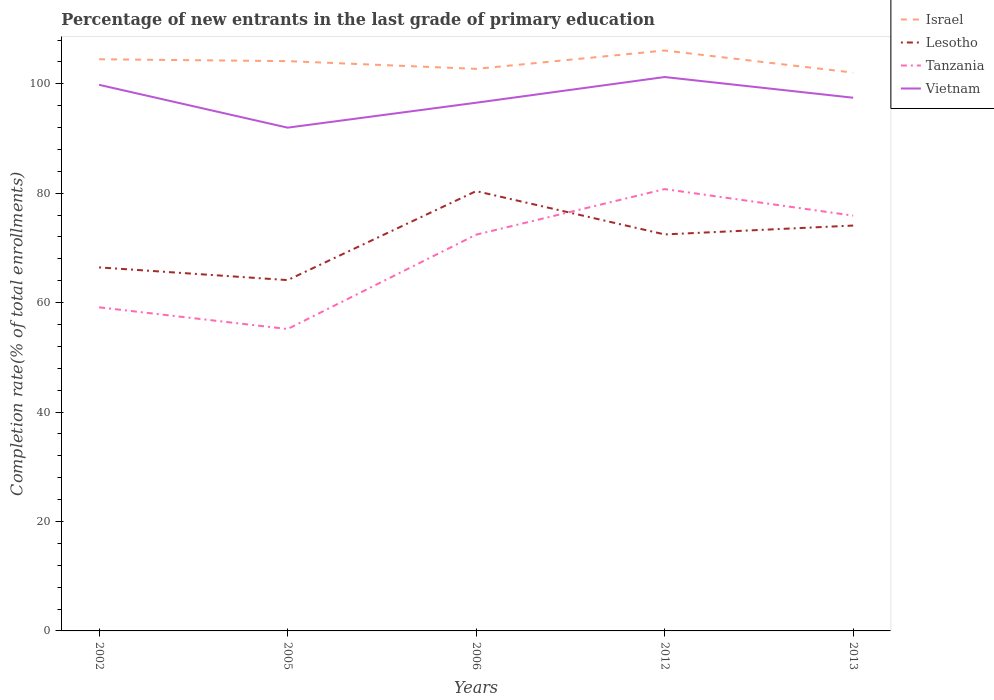Across all years, what is the maximum percentage of new entrants in Lesotho?
Offer a terse response. 64.12. What is the total percentage of new entrants in Vietnam in the graph?
Offer a very short reply. -1.42. What is the difference between the highest and the second highest percentage of new entrants in Israel?
Your response must be concise. 4.04. How many years are there in the graph?
Your response must be concise. 5. What is the difference between two consecutive major ticks on the Y-axis?
Your answer should be compact. 20. Does the graph contain any zero values?
Your answer should be compact. No. Does the graph contain grids?
Offer a very short reply. No. Where does the legend appear in the graph?
Provide a succinct answer. Top right. What is the title of the graph?
Your answer should be compact. Percentage of new entrants in the last grade of primary education. What is the label or title of the X-axis?
Provide a short and direct response. Years. What is the label or title of the Y-axis?
Your response must be concise. Completion rate(% of total enrollments). What is the Completion rate(% of total enrollments) in Israel in 2002?
Ensure brevity in your answer.  104.48. What is the Completion rate(% of total enrollments) of Lesotho in 2002?
Provide a succinct answer. 66.44. What is the Completion rate(% of total enrollments) in Tanzania in 2002?
Your response must be concise. 59.14. What is the Completion rate(% of total enrollments) of Vietnam in 2002?
Give a very brief answer. 99.81. What is the Completion rate(% of total enrollments) of Israel in 2005?
Make the answer very short. 104.14. What is the Completion rate(% of total enrollments) in Lesotho in 2005?
Ensure brevity in your answer.  64.12. What is the Completion rate(% of total enrollments) of Tanzania in 2005?
Keep it short and to the point. 55.18. What is the Completion rate(% of total enrollments) in Vietnam in 2005?
Provide a succinct answer. 91.98. What is the Completion rate(% of total enrollments) in Israel in 2006?
Provide a short and direct response. 102.73. What is the Completion rate(% of total enrollments) in Lesotho in 2006?
Offer a very short reply. 80.39. What is the Completion rate(% of total enrollments) in Tanzania in 2006?
Ensure brevity in your answer.  72.42. What is the Completion rate(% of total enrollments) of Vietnam in 2006?
Give a very brief answer. 96.54. What is the Completion rate(% of total enrollments) in Israel in 2012?
Offer a terse response. 106.08. What is the Completion rate(% of total enrollments) of Lesotho in 2012?
Give a very brief answer. 72.47. What is the Completion rate(% of total enrollments) of Tanzania in 2012?
Provide a short and direct response. 80.75. What is the Completion rate(% of total enrollments) in Vietnam in 2012?
Offer a very short reply. 101.24. What is the Completion rate(% of total enrollments) of Israel in 2013?
Keep it short and to the point. 102.05. What is the Completion rate(% of total enrollments) in Lesotho in 2013?
Provide a succinct answer. 74.09. What is the Completion rate(% of total enrollments) of Tanzania in 2013?
Your answer should be very brief. 75.9. What is the Completion rate(% of total enrollments) of Vietnam in 2013?
Provide a short and direct response. 97.45. Across all years, what is the maximum Completion rate(% of total enrollments) in Israel?
Keep it short and to the point. 106.08. Across all years, what is the maximum Completion rate(% of total enrollments) of Lesotho?
Make the answer very short. 80.39. Across all years, what is the maximum Completion rate(% of total enrollments) in Tanzania?
Provide a short and direct response. 80.75. Across all years, what is the maximum Completion rate(% of total enrollments) in Vietnam?
Give a very brief answer. 101.24. Across all years, what is the minimum Completion rate(% of total enrollments) in Israel?
Keep it short and to the point. 102.05. Across all years, what is the minimum Completion rate(% of total enrollments) in Lesotho?
Offer a terse response. 64.12. Across all years, what is the minimum Completion rate(% of total enrollments) of Tanzania?
Provide a short and direct response. 55.18. Across all years, what is the minimum Completion rate(% of total enrollments) of Vietnam?
Keep it short and to the point. 91.98. What is the total Completion rate(% of total enrollments) of Israel in the graph?
Your response must be concise. 519.48. What is the total Completion rate(% of total enrollments) in Lesotho in the graph?
Offer a terse response. 357.51. What is the total Completion rate(% of total enrollments) in Tanzania in the graph?
Make the answer very short. 343.4. What is the total Completion rate(% of total enrollments) of Vietnam in the graph?
Offer a terse response. 487.02. What is the difference between the Completion rate(% of total enrollments) of Israel in 2002 and that in 2005?
Offer a terse response. 0.34. What is the difference between the Completion rate(% of total enrollments) in Lesotho in 2002 and that in 2005?
Ensure brevity in your answer.  2.32. What is the difference between the Completion rate(% of total enrollments) of Tanzania in 2002 and that in 2005?
Keep it short and to the point. 3.97. What is the difference between the Completion rate(% of total enrollments) in Vietnam in 2002 and that in 2005?
Make the answer very short. 7.83. What is the difference between the Completion rate(% of total enrollments) of Israel in 2002 and that in 2006?
Keep it short and to the point. 1.76. What is the difference between the Completion rate(% of total enrollments) of Lesotho in 2002 and that in 2006?
Your answer should be compact. -13.94. What is the difference between the Completion rate(% of total enrollments) in Tanzania in 2002 and that in 2006?
Give a very brief answer. -13.28. What is the difference between the Completion rate(% of total enrollments) of Vietnam in 2002 and that in 2006?
Make the answer very short. 3.27. What is the difference between the Completion rate(% of total enrollments) of Israel in 2002 and that in 2012?
Provide a succinct answer. -1.6. What is the difference between the Completion rate(% of total enrollments) of Lesotho in 2002 and that in 2012?
Give a very brief answer. -6.03. What is the difference between the Completion rate(% of total enrollments) of Tanzania in 2002 and that in 2012?
Provide a succinct answer. -21.61. What is the difference between the Completion rate(% of total enrollments) of Vietnam in 2002 and that in 2012?
Your answer should be very brief. -1.42. What is the difference between the Completion rate(% of total enrollments) in Israel in 2002 and that in 2013?
Offer a terse response. 2.44. What is the difference between the Completion rate(% of total enrollments) in Lesotho in 2002 and that in 2013?
Give a very brief answer. -7.65. What is the difference between the Completion rate(% of total enrollments) in Tanzania in 2002 and that in 2013?
Your answer should be very brief. -16.76. What is the difference between the Completion rate(% of total enrollments) of Vietnam in 2002 and that in 2013?
Your response must be concise. 2.36. What is the difference between the Completion rate(% of total enrollments) of Israel in 2005 and that in 2006?
Your answer should be very brief. 1.42. What is the difference between the Completion rate(% of total enrollments) in Lesotho in 2005 and that in 2006?
Offer a very short reply. -16.27. What is the difference between the Completion rate(% of total enrollments) in Tanzania in 2005 and that in 2006?
Offer a very short reply. -17.24. What is the difference between the Completion rate(% of total enrollments) in Vietnam in 2005 and that in 2006?
Make the answer very short. -4.56. What is the difference between the Completion rate(% of total enrollments) in Israel in 2005 and that in 2012?
Your answer should be very brief. -1.94. What is the difference between the Completion rate(% of total enrollments) in Lesotho in 2005 and that in 2012?
Provide a succinct answer. -8.35. What is the difference between the Completion rate(% of total enrollments) in Tanzania in 2005 and that in 2012?
Your answer should be compact. -25.57. What is the difference between the Completion rate(% of total enrollments) in Vietnam in 2005 and that in 2012?
Offer a terse response. -9.25. What is the difference between the Completion rate(% of total enrollments) of Israel in 2005 and that in 2013?
Ensure brevity in your answer.  2.1. What is the difference between the Completion rate(% of total enrollments) in Lesotho in 2005 and that in 2013?
Make the answer very short. -9.97. What is the difference between the Completion rate(% of total enrollments) of Tanzania in 2005 and that in 2013?
Make the answer very short. -20.73. What is the difference between the Completion rate(% of total enrollments) of Vietnam in 2005 and that in 2013?
Offer a very short reply. -5.47. What is the difference between the Completion rate(% of total enrollments) in Israel in 2006 and that in 2012?
Provide a succinct answer. -3.36. What is the difference between the Completion rate(% of total enrollments) of Lesotho in 2006 and that in 2012?
Your answer should be compact. 7.92. What is the difference between the Completion rate(% of total enrollments) of Tanzania in 2006 and that in 2012?
Keep it short and to the point. -8.33. What is the difference between the Completion rate(% of total enrollments) in Vietnam in 2006 and that in 2012?
Give a very brief answer. -4.7. What is the difference between the Completion rate(% of total enrollments) in Israel in 2006 and that in 2013?
Provide a succinct answer. 0.68. What is the difference between the Completion rate(% of total enrollments) in Lesotho in 2006 and that in 2013?
Provide a short and direct response. 6.3. What is the difference between the Completion rate(% of total enrollments) of Tanzania in 2006 and that in 2013?
Provide a succinct answer. -3.48. What is the difference between the Completion rate(% of total enrollments) of Vietnam in 2006 and that in 2013?
Give a very brief answer. -0.91. What is the difference between the Completion rate(% of total enrollments) in Israel in 2012 and that in 2013?
Offer a very short reply. 4.04. What is the difference between the Completion rate(% of total enrollments) of Lesotho in 2012 and that in 2013?
Offer a terse response. -1.62. What is the difference between the Completion rate(% of total enrollments) in Tanzania in 2012 and that in 2013?
Your answer should be compact. 4.85. What is the difference between the Completion rate(% of total enrollments) of Vietnam in 2012 and that in 2013?
Your response must be concise. 3.78. What is the difference between the Completion rate(% of total enrollments) of Israel in 2002 and the Completion rate(% of total enrollments) of Lesotho in 2005?
Provide a succinct answer. 40.36. What is the difference between the Completion rate(% of total enrollments) of Israel in 2002 and the Completion rate(% of total enrollments) of Tanzania in 2005?
Give a very brief answer. 49.31. What is the difference between the Completion rate(% of total enrollments) in Israel in 2002 and the Completion rate(% of total enrollments) in Vietnam in 2005?
Keep it short and to the point. 12.5. What is the difference between the Completion rate(% of total enrollments) in Lesotho in 2002 and the Completion rate(% of total enrollments) in Tanzania in 2005?
Your answer should be compact. 11.26. What is the difference between the Completion rate(% of total enrollments) in Lesotho in 2002 and the Completion rate(% of total enrollments) in Vietnam in 2005?
Ensure brevity in your answer.  -25.54. What is the difference between the Completion rate(% of total enrollments) in Tanzania in 2002 and the Completion rate(% of total enrollments) in Vietnam in 2005?
Give a very brief answer. -32.84. What is the difference between the Completion rate(% of total enrollments) of Israel in 2002 and the Completion rate(% of total enrollments) of Lesotho in 2006?
Offer a terse response. 24.1. What is the difference between the Completion rate(% of total enrollments) of Israel in 2002 and the Completion rate(% of total enrollments) of Tanzania in 2006?
Provide a succinct answer. 32.06. What is the difference between the Completion rate(% of total enrollments) in Israel in 2002 and the Completion rate(% of total enrollments) in Vietnam in 2006?
Make the answer very short. 7.95. What is the difference between the Completion rate(% of total enrollments) of Lesotho in 2002 and the Completion rate(% of total enrollments) of Tanzania in 2006?
Your answer should be compact. -5.98. What is the difference between the Completion rate(% of total enrollments) in Lesotho in 2002 and the Completion rate(% of total enrollments) in Vietnam in 2006?
Offer a very short reply. -30.1. What is the difference between the Completion rate(% of total enrollments) in Tanzania in 2002 and the Completion rate(% of total enrollments) in Vietnam in 2006?
Ensure brevity in your answer.  -37.39. What is the difference between the Completion rate(% of total enrollments) in Israel in 2002 and the Completion rate(% of total enrollments) in Lesotho in 2012?
Keep it short and to the point. 32.02. What is the difference between the Completion rate(% of total enrollments) of Israel in 2002 and the Completion rate(% of total enrollments) of Tanzania in 2012?
Make the answer very short. 23.73. What is the difference between the Completion rate(% of total enrollments) of Israel in 2002 and the Completion rate(% of total enrollments) of Vietnam in 2012?
Your response must be concise. 3.25. What is the difference between the Completion rate(% of total enrollments) of Lesotho in 2002 and the Completion rate(% of total enrollments) of Tanzania in 2012?
Offer a terse response. -14.31. What is the difference between the Completion rate(% of total enrollments) of Lesotho in 2002 and the Completion rate(% of total enrollments) of Vietnam in 2012?
Offer a terse response. -34.79. What is the difference between the Completion rate(% of total enrollments) in Tanzania in 2002 and the Completion rate(% of total enrollments) in Vietnam in 2012?
Provide a succinct answer. -42.09. What is the difference between the Completion rate(% of total enrollments) in Israel in 2002 and the Completion rate(% of total enrollments) in Lesotho in 2013?
Provide a succinct answer. 30.39. What is the difference between the Completion rate(% of total enrollments) in Israel in 2002 and the Completion rate(% of total enrollments) in Tanzania in 2013?
Your response must be concise. 28.58. What is the difference between the Completion rate(% of total enrollments) of Israel in 2002 and the Completion rate(% of total enrollments) of Vietnam in 2013?
Your response must be concise. 7.03. What is the difference between the Completion rate(% of total enrollments) of Lesotho in 2002 and the Completion rate(% of total enrollments) of Tanzania in 2013?
Provide a succinct answer. -9.46. What is the difference between the Completion rate(% of total enrollments) of Lesotho in 2002 and the Completion rate(% of total enrollments) of Vietnam in 2013?
Provide a succinct answer. -31.01. What is the difference between the Completion rate(% of total enrollments) of Tanzania in 2002 and the Completion rate(% of total enrollments) of Vietnam in 2013?
Offer a very short reply. -38.31. What is the difference between the Completion rate(% of total enrollments) in Israel in 2005 and the Completion rate(% of total enrollments) in Lesotho in 2006?
Ensure brevity in your answer.  23.76. What is the difference between the Completion rate(% of total enrollments) of Israel in 2005 and the Completion rate(% of total enrollments) of Tanzania in 2006?
Offer a terse response. 31.72. What is the difference between the Completion rate(% of total enrollments) in Israel in 2005 and the Completion rate(% of total enrollments) in Vietnam in 2006?
Offer a terse response. 7.6. What is the difference between the Completion rate(% of total enrollments) of Lesotho in 2005 and the Completion rate(% of total enrollments) of Tanzania in 2006?
Offer a terse response. -8.3. What is the difference between the Completion rate(% of total enrollments) in Lesotho in 2005 and the Completion rate(% of total enrollments) in Vietnam in 2006?
Ensure brevity in your answer.  -32.42. What is the difference between the Completion rate(% of total enrollments) in Tanzania in 2005 and the Completion rate(% of total enrollments) in Vietnam in 2006?
Offer a terse response. -41.36. What is the difference between the Completion rate(% of total enrollments) of Israel in 2005 and the Completion rate(% of total enrollments) of Lesotho in 2012?
Make the answer very short. 31.67. What is the difference between the Completion rate(% of total enrollments) in Israel in 2005 and the Completion rate(% of total enrollments) in Tanzania in 2012?
Your response must be concise. 23.39. What is the difference between the Completion rate(% of total enrollments) of Israel in 2005 and the Completion rate(% of total enrollments) of Vietnam in 2012?
Provide a short and direct response. 2.91. What is the difference between the Completion rate(% of total enrollments) in Lesotho in 2005 and the Completion rate(% of total enrollments) in Tanzania in 2012?
Give a very brief answer. -16.63. What is the difference between the Completion rate(% of total enrollments) in Lesotho in 2005 and the Completion rate(% of total enrollments) in Vietnam in 2012?
Keep it short and to the point. -37.12. What is the difference between the Completion rate(% of total enrollments) in Tanzania in 2005 and the Completion rate(% of total enrollments) in Vietnam in 2012?
Keep it short and to the point. -46.06. What is the difference between the Completion rate(% of total enrollments) in Israel in 2005 and the Completion rate(% of total enrollments) in Lesotho in 2013?
Your response must be concise. 30.05. What is the difference between the Completion rate(% of total enrollments) in Israel in 2005 and the Completion rate(% of total enrollments) in Tanzania in 2013?
Give a very brief answer. 28.24. What is the difference between the Completion rate(% of total enrollments) of Israel in 2005 and the Completion rate(% of total enrollments) of Vietnam in 2013?
Keep it short and to the point. 6.69. What is the difference between the Completion rate(% of total enrollments) of Lesotho in 2005 and the Completion rate(% of total enrollments) of Tanzania in 2013?
Give a very brief answer. -11.78. What is the difference between the Completion rate(% of total enrollments) in Lesotho in 2005 and the Completion rate(% of total enrollments) in Vietnam in 2013?
Offer a very short reply. -33.33. What is the difference between the Completion rate(% of total enrollments) in Tanzania in 2005 and the Completion rate(% of total enrollments) in Vietnam in 2013?
Provide a succinct answer. -42.27. What is the difference between the Completion rate(% of total enrollments) in Israel in 2006 and the Completion rate(% of total enrollments) in Lesotho in 2012?
Offer a very short reply. 30.26. What is the difference between the Completion rate(% of total enrollments) in Israel in 2006 and the Completion rate(% of total enrollments) in Tanzania in 2012?
Your response must be concise. 21.97. What is the difference between the Completion rate(% of total enrollments) in Israel in 2006 and the Completion rate(% of total enrollments) in Vietnam in 2012?
Offer a terse response. 1.49. What is the difference between the Completion rate(% of total enrollments) in Lesotho in 2006 and the Completion rate(% of total enrollments) in Tanzania in 2012?
Your answer should be very brief. -0.37. What is the difference between the Completion rate(% of total enrollments) in Lesotho in 2006 and the Completion rate(% of total enrollments) in Vietnam in 2012?
Provide a short and direct response. -20.85. What is the difference between the Completion rate(% of total enrollments) in Tanzania in 2006 and the Completion rate(% of total enrollments) in Vietnam in 2012?
Offer a terse response. -28.81. What is the difference between the Completion rate(% of total enrollments) in Israel in 2006 and the Completion rate(% of total enrollments) in Lesotho in 2013?
Provide a short and direct response. 28.64. What is the difference between the Completion rate(% of total enrollments) in Israel in 2006 and the Completion rate(% of total enrollments) in Tanzania in 2013?
Provide a short and direct response. 26.82. What is the difference between the Completion rate(% of total enrollments) in Israel in 2006 and the Completion rate(% of total enrollments) in Vietnam in 2013?
Keep it short and to the point. 5.27. What is the difference between the Completion rate(% of total enrollments) in Lesotho in 2006 and the Completion rate(% of total enrollments) in Tanzania in 2013?
Keep it short and to the point. 4.48. What is the difference between the Completion rate(% of total enrollments) of Lesotho in 2006 and the Completion rate(% of total enrollments) of Vietnam in 2013?
Make the answer very short. -17.07. What is the difference between the Completion rate(% of total enrollments) in Tanzania in 2006 and the Completion rate(% of total enrollments) in Vietnam in 2013?
Offer a very short reply. -25.03. What is the difference between the Completion rate(% of total enrollments) of Israel in 2012 and the Completion rate(% of total enrollments) of Lesotho in 2013?
Your answer should be compact. 31.99. What is the difference between the Completion rate(% of total enrollments) of Israel in 2012 and the Completion rate(% of total enrollments) of Tanzania in 2013?
Provide a succinct answer. 30.18. What is the difference between the Completion rate(% of total enrollments) in Israel in 2012 and the Completion rate(% of total enrollments) in Vietnam in 2013?
Your answer should be very brief. 8.63. What is the difference between the Completion rate(% of total enrollments) in Lesotho in 2012 and the Completion rate(% of total enrollments) in Tanzania in 2013?
Provide a short and direct response. -3.44. What is the difference between the Completion rate(% of total enrollments) in Lesotho in 2012 and the Completion rate(% of total enrollments) in Vietnam in 2013?
Make the answer very short. -24.98. What is the difference between the Completion rate(% of total enrollments) of Tanzania in 2012 and the Completion rate(% of total enrollments) of Vietnam in 2013?
Keep it short and to the point. -16.7. What is the average Completion rate(% of total enrollments) of Israel per year?
Offer a very short reply. 103.9. What is the average Completion rate(% of total enrollments) of Lesotho per year?
Ensure brevity in your answer.  71.5. What is the average Completion rate(% of total enrollments) of Tanzania per year?
Make the answer very short. 68.68. What is the average Completion rate(% of total enrollments) in Vietnam per year?
Your response must be concise. 97.4. In the year 2002, what is the difference between the Completion rate(% of total enrollments) in Israel and Completion rate(% of total enrollments) in Lesotho?
Give a very brief answer. 38.04. In the year 2002, what is the difference between the Completion rate(% of total enrollments) in Israel and Completion rate(% of total enrollments) in Tanzania?
Your answer should be compact. 45.34. In the year 2002, what is the difference between the Completion rate(% of total enrollments) of Israel and Completion rate(% of total enrollments) of Vietnam?
Your answer should be very brief. 4.67. In the year 2002, what is the difference between the Completion rate(% of total enrollments) in Lesotho and Completion rate(% of total enrollments) in Tanzania?
Keep it short and to the point. 7.3. In the year 2002, what is the difference between the Completion rate(% of total enrollments) of Lesotho and Completion rate(% of total enrollments) of Vietnam?
Offer a very short reply. -33.37. In the year 2002, what is the difference between the Completion rate(% of total enrollments) of Tanzania and Completion rate(% of total enrollments) of Vietnam?
Keep it short and to the point. -40.67. In the year 2005, what is the difference between the Completion rate(% of total enrollments) of Israel and Completion rate(% of total enrollments) of Lesotho?
Your answer should be very brief. 40.02. In the year 2005, what is the difference between the Completion rate(% of total enrollments) in Israel and Completion rate(% of total enrollments) in Tanzania?
Offer a terse response. 48.96. In the year 2005, what is the difference between the Completion rate(% of total enrollments) of Israel and Completion rate(% of total enrollments) of Vietnam?
Your answer should be very brief. 12.16. In the year 2005, what is the difference between the Completion rate(% of total enrollments) in Lesotho and Completion rate(% of total enrollments) in Tanzania?
Provide a succinct answer. 8.94. In the year 2005, what is the difference between the Completion rate(% of total enrollments) of Lesotho and Completion rate(% of total enrollments) of Vietnam?
Make the answer very short. -27.86. In the year 2005, what is the difference between the Completion rate(% of total enrollments) of Tanzania and Completion rate(% of total enrollments) of Vietnam?
Offer a terse response. -36.8. In the year 2006, what is the difference between the Completion rate(% of total enrollments) of Israel and Completion rate(% of total enrollments) of Lesotho?
Provide a short and direct response. 22.34. In the year 2006, what is the difference between the Completion rate(% of total enrollments) in Israel and Completion rate(% of total enrollments) in Tanzania?
Provide a short and direct response. 30.3. In the year 2006, what is the difference between the Completion rate(% of total enrollments) of Israel and Completion rate(% of total enrollments) of Vietnam?
Your answer should be very brief. 6.19. In the year 2006, what is the difference between the Completion rate(% of total enrollments) of Lesotho and Completion rate(% of total enrollments) of Tanzania?
Provide a short and direct response. 7.96. In the year 2006, what is the difference between the Completion rate(% of total enrollments) of Lesotho and Completion rate(% of total enrollments) of Vietnam?
Make the answer very short. -16.15. In the year 2006, what is the difference between the Completion rate(% of total enrollments) in Tanzania and Completion rate(% of total enrollments) in Vietnam?
Provide a short and direct response. -24.12. In the year 2012, what is the difference between the Completion rate(% of total enrollments) in Israel and Completion rate(% of total enrollments) in Lesotho?
Ensure brevity in your answer.  33.62. In the year 2012, what is the difference between the Completion rate(% of total enrollments) of Israel and Completion rate(% of total enrollments) of Tanzania?
Offer a terse response. 25.33. In the year 2012, what is the difference between the Completion rate(% of total enrollments) of Israel and Completion rate(% of total enrollments) of Vietnam?
Your answer should be compact. 4.85. In the year 2012, what is the difference between the Completion rate(% of total enrollments) in Lesotho and Completion rate(% of total enrollments) in Tanzania?
Make the answer very short. -8.28. In the year 2012, what is the difference between the Completion rate(% of total enrollments) of Lesotho and Completion rate(% of total enrollments) of Vietnam?
Keep it short and to the point. -28.77. In the year 2012, what is the difference between the Completion rate(% of total enrollments) in Tanzania and Completion rate(% of total enrollments) in Vietnam?
Offer a terse response. -20.48. In the year 2013, what is the difference between the Completion rate(% of total enrollments) in Israel and Completion rate(% of total enrollments) in Lesotho?
Offer a terse response. 27.96. In the year 2013, what is the difference between the Completion rate(% of total enrollments) in Israel and Completion rate(% of total enrollments) in Tanzania?
Your answer should be compact. 26.14. In the year 2013, what is the difference between the Completion rate(% of total enrollments) of Israel and Completion rate(% of total enrollments) of Vietnam?
Give a very brief answer. 4.59. In the year 2013, what is the difference between the Completion rate(% of total enrollments) of Lesotho and Completion rate(% of total enrollments) of Tanzania?
Provide a succinct answer. -1.81. In the year 2013, what is the difference between the Completion rate(% of total enrollments) of Lesotho and Completion rate(% of total enrollments) of Vietnam?
Your answer should be very brief. -23.36. In the year 2013, what is the difference between the Completion rate(% of total enrollments) of Tanzania and Completion rate(% of total enrollments) of Vietnam?
Your answer should be compact. -21.55. What is the ratio of the Completion rate(% of total enrollments) of Lesotho in 2002 to that in 2005?
Give a very brief answer. 1.04. What is the ratio of the Completion rate(% of total enrollments) of Tanzania in 2002 to that in 2005?
Provide a succinct answer. 1.07. What is the ratio of the Completion rate(% of total enrollments) in Vietnam in 2002 to that in 2005?
Your answer should be very brief. 1.09. What is the ratio of the Completion rate(% of total enrollments) of Israel in 2002 to that in 2006?
Offer a terse response. 1.02. What is the ratio of the Completion rate(% of total enrollments) of Lesotho in 2002 to that in 2006?
Keep it short and to the point. 0.83. What is the ratio of the Completion rate(% of total enrollments) in Tanzania in 2002 to that in 2006?
Ensure brevity in your answer.  0.82. What is the ratio of the Completion rate(% of total enrollments) of Vietnam in 2002 to that in 2006?
Provide a short and direct response. 1.03. What is the ratio of the Completion rate(% of total enrollments) of Israel in 2002 to that in 2012?
Your response must be concise. 0.98. What is the ratio of the Completion rate(% of total enrollments) in Lesotho in 2002 to that in 2012?
Offer a very short reply. 0.92. What is the ratio of the Completion rate(% of total enrollments) in Tanzania in 2002 to that in 2012?
Offer a terse response. 0.73. What is the ratio of the Completion rate(% of total enrollments) in Vietnam in 2002 to that in 2012?
Give a very brief answer. 0.99. What is the ratio of the Completion rate(% of total enrollments) of Israel in 2002 to that in 2013?
Provide a succinct answer. 1.02. What is the ratio of the Completion rate(% of total enrollments) in Lesotho in 2002 to that in 2013?
Provide a short and direct response. 0.9. What is the ratio of the Completion rate(% of total enrollments) in Tanzania in 2002 to that in 2013?
Give a very brief answer. 0.78. What is the ratio of the Completion rate(% of total enrollments) in Vietnam in 2002 to that in 2013?
Your response must be concise. 1.02. What is the ratio of the Completion rate(% of total enrollments) in Israel in 2005 to that in 2006?
Offer a terse response. 1.01. What is the ratio of the Completion rate(% of total enrollments) of Lesotho in 2005 to that in 2006?
Provide a short and direct response. 0.8. What is the ratio of the Completion rate(% of total enrollments) of Tanzania in 2005 to that in 2006?
Your answer should be compact. 0.76. What is the ratio of the Completion rate(% of total enrollments) of Vietnam in 2005 to that in 2006?
Your answer should be compact. 0.95. What is the ratio of the Completion rate(% of total enrollments) in Israel in 2005 to that in 2012?
Your answer should be very brief. 0.98. What is the ratio of the Completion rate(% of total enrollments) in Lesotho in 2005 to that in 2012?
Your answer should be compact. 0.88. What is the ratio of the Completion rate(% of total enrollments) in Tanzania in 2005 to that in 2012?
Your answer should be very brief. 0.68. What is the ratio of the Completion rate(% of total enrollments) of Vietnam in 2005 to that in 2012?
Offer a terse response. 0.91. What is the ratio of the Completion rate(% of total enrollments) of Israel in 2005 to that in 2013?
Your answer should be compact. 1.02. What is the ratio of the Completion rate(% of total enrollments) of Lesotho in 2005 to that in 2013?
Keep it short and to the point. 0.87. What is the ratio of the Completion rate(% of total enrollments) of Tanzania in 2005 to that in 2013?
Provide a succinct answer. 0.73. What is the ratio of the Completion rate(% of total enrollments) in Vietnam in 2005 to that in 2013?
Offer a very short reply. 0.94. What is the ratio of the Completion rate(% of total enrollments) of Israel in 2006 to that in 2012?
Offer a terse response. 0.97. What is the ratio of the Completion rate(% of total enrollments) in Lesotho in 2006 to that in 2012?
Your response must be concise. 1.11. What is the ratio of the Completion rate(% of total enrollments) in Tanzania in 2006 to that in 2012?
Keep it short and to the point. 0.9. What is the ratio of the Completion rate(% of total enrollments) of Vietnam in 2006 to that in 2012?
Make the answer very short. 0.95. What is the ratio of the Completion rate(% of total enrollments) in Israel in 2006 to that in 2013?
Offer a terse response. 1.01. What is the ratio of the Completion rate(% of total enrollments) in Lesotho in 2006 to that in 2013?
Your answer should be compact. 1.08. What is the ratio of the Completion rate(% of total enrollments) of Tanzania in 2006 to that in 2013?
Your answer should be very brief. 0.95. What is the ratio of the Completion rate(% of total enrollments) in Vietnam in 2006 to that in 2013?
Ensure brevity in your answer.  0.99. What is the ratio of the Completion rate(% of total enrollments) of Israel in 2012 to that in 2013?
Give a very brief answer. 1.04. What is the ratio of the Completion rate(% of total enrollments) in Lesotho in 2012 to that in 2013?
Provide a succinct answer. 0.98. What is the ratio of the Completion rate(% of total enrollments) in Tanzania in 2012 to that in 2013?
Provide a short and direct response. 1.06. What is the ratio of the Completion rate(% of total enrollments) in Vietnam in 2012 to that in 2013?
Your answer should be compact. 1.04. What is the difference between the highest and the second highest Completion rate(% of total enrollments) of Israel?
Your answer should be very brief. 1.6. What is the difference between the highest and the second highest Completion rate(% of total enrollments) in Lesotho?
Your response must be concise. 6.3. What is the difference between the highest and the second highest Completion rate(% of total enrollments) in Tanzania?
Give a very brief answer. 4.85. What is the difference between the highest and the second highest Completion rate(% of total enrollments) in Vietnam?
Your answer should be compact. 1.42. What is the difference between the highest and the lowest Completion rate(% of total enrollments) of Israel?
Offer a very short reply. 4.04. What is the difference between the highest and the lowest Completion rate(% of total enrollments) of Lesotho?
Give a very brief answer. 16.27. What is the difference between the highest and the lowest Completion rate(% of total enrollments) in Tanzania?
Provide a succinct answer. 25.57. What is the difference between the highest and the lowest Completion rate(% of total enrollments) in Vietnam?
Ensure brevity in your answer.  9.25. 